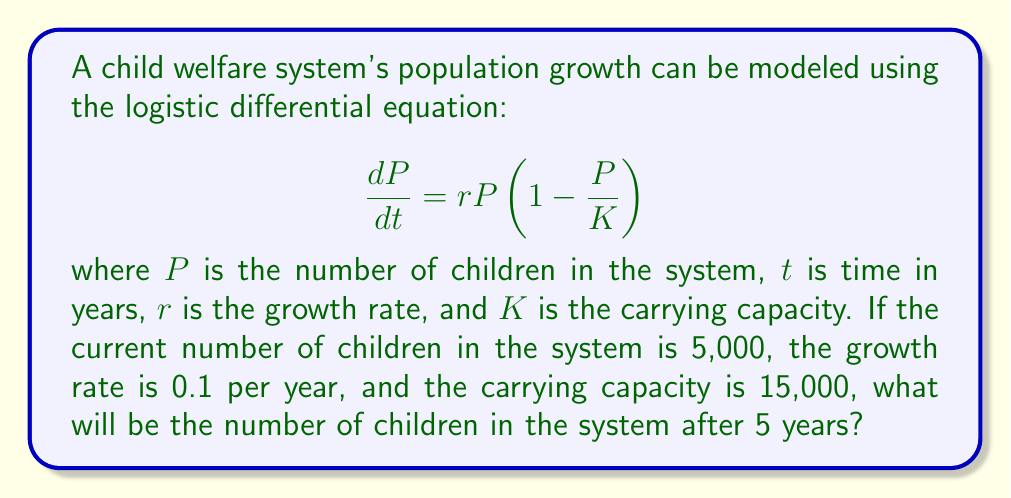Provide a solution to this math problem. To solve this problem, we need to use the solution to the logistic differential equation:

$$P(t) = \frac{K}{1 + \left(\frac{K}{P_0} - 1\right)e^{-rt}}$$

Where:
$P(t)$ is the population at time $t$
$K$ is the carrying capacity
$P_0$ is the initial population
$r$ is the growth rate
$t$ is the time

Given:
$P_0 = 5,000$
$K = 15,000$
$r = 0.1$
$t = 5$ years

Let's substitute these values into the equation:

$$P(5) = \frac{15,000}{1 + \left(\frac{15,000}{5,000} - 1\right)e^{-0.1 \cdot 5}}$$

Simplifying:

$$P(5) = \frac{15,000}{1 + (3 - 1)e^{-0.5}}$$
$$P(5) = \frac{15,000}{1 + 2e^{-0.5}}$$

Now, let's calculate $e^{-0.5}$:
$e^{-0.5} \approx 0.6065$

Substituting this value:

$$P(5) = \frac{15,000}{1 + 2(0.6065)}$$
$$P(5) = \frac{15,000}{2.213}$$
$$P(5) \approx 6,778$$

Rounding to the nearest whole number, as we're dealing with children, we get 6,778 children in the system after 5 years.
Answer: 6,778 children 